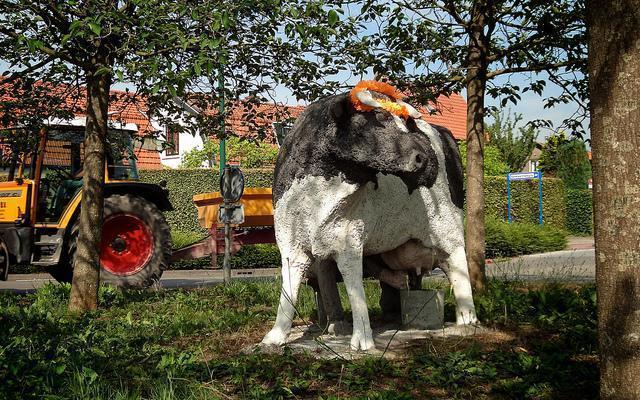What feature of the animal is visible?
Make your selection from the four choices given to correctly answer the question.
Options: Wing, gill, udder, stinger. Udder. 